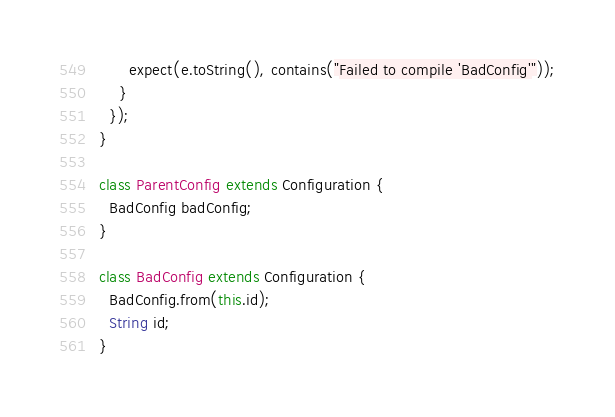<code> <loc_0><loc_0><loc_500><loc_500><_Dart_>      expect(e.toString(), contains("Failed to compile 'BadConfig'"));
    }
  });
}

class ParentConfig extends Configuration {
  BadConfig badConfig;
}

class BadConfig extends Configuration {
  BadConfig.from(this.id);
  String id;
}
</code> 